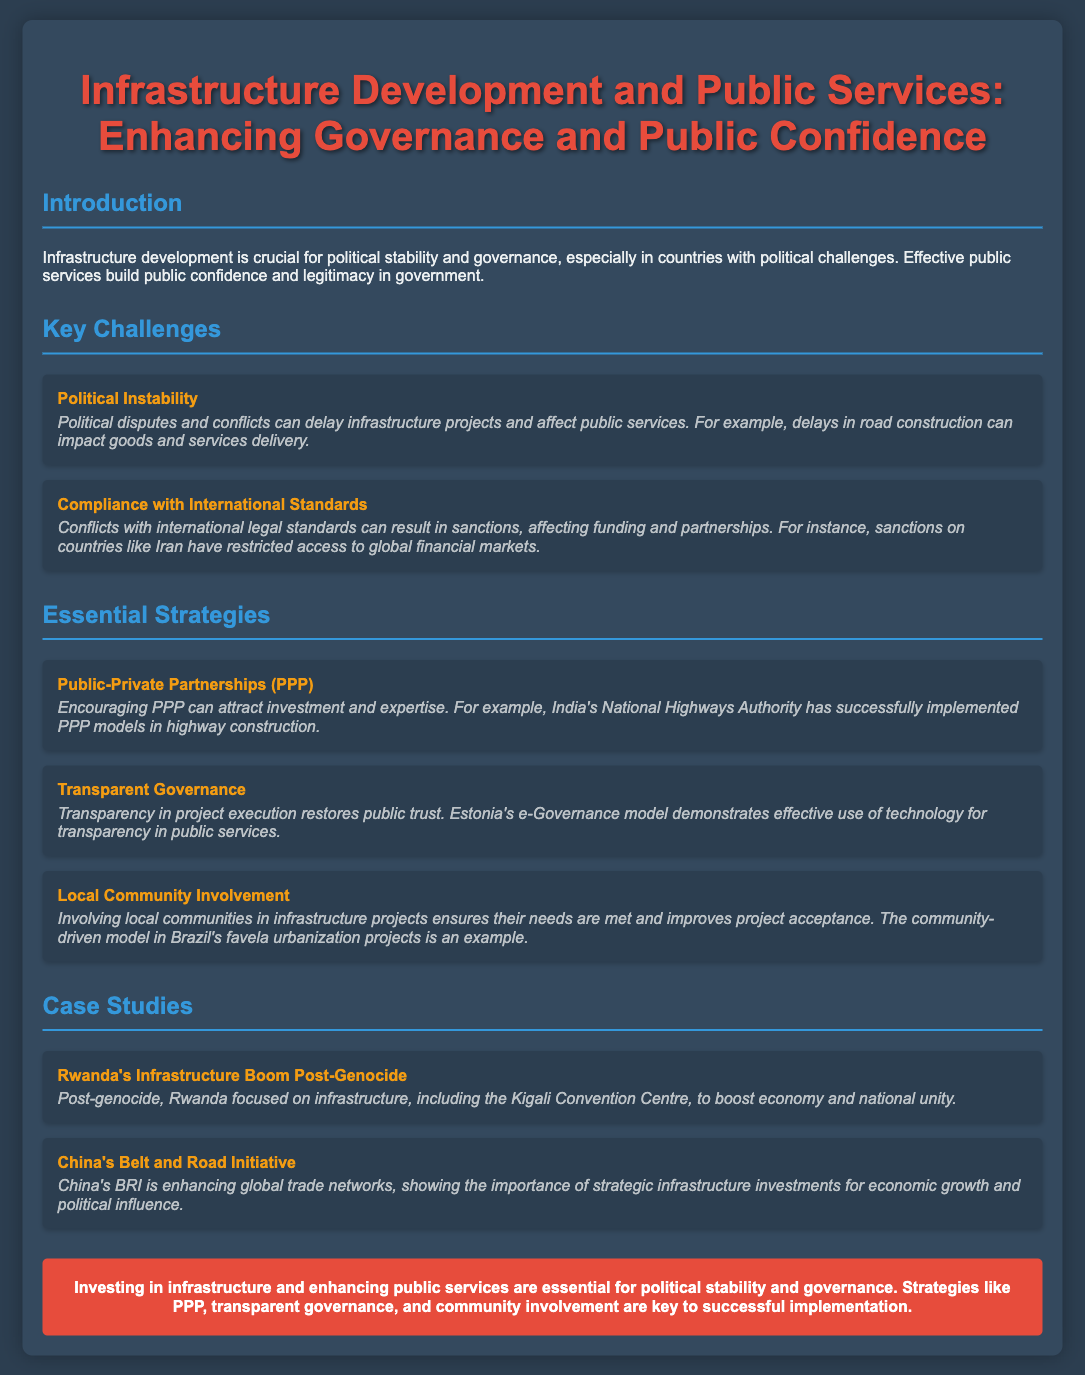What is the main title of the presentation? The title of the presentation is specified at the top of the document.
Answer: Infrastructure Development and Public Services: Enhancing Governance and Public Confidence What is a key challenge mentioned related to political instability? The document lists challenges and gives an example of how political instability can delay projects.
Answer: Delays in infrastructure projects Which essential strategy involves investment attraction? This strategy is outlined as a way to enhance infrastructure development.
Answer: Public-Private Partnerships (PPP) What is the case study featuring Rwanda focused on? The case study discusses Rwanda's actions post-genocide related to infrastructure.
Answer: Infrastructure Boom Post-Genocide Which country is associated with the Belt and Road Initiative? The document mentions a specific country related to the case study.
Answer: China What technological model is cited to demonstrate transparent governance? An example of a country's governance model is provided to illustrate transparency.
Answer: Estonia's e-Governance model What effect does involving local communities have on projects? The document states a particular outcome of local community involvement in projects.
Answer: Improves project acceptance What is emphasized as essential for political stability in the conclusion? The conclusion summarizes key points made throughout the presentation, including the focus on investment.
Answer: Investing in infrastructure 